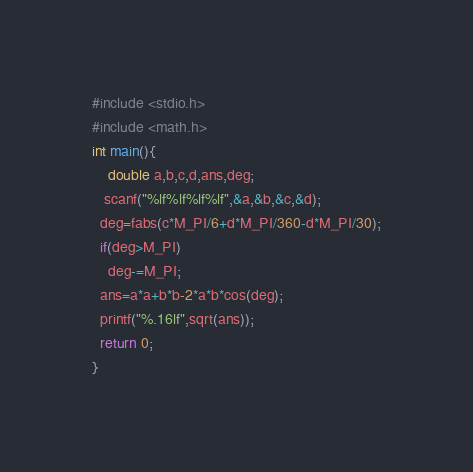<code> <loc_0><loc_0><loc_500><loc_500><_C_>#include <stdio.h>
#include <math.h>
int main(){
    double a,b,c,d,ans,deg;
   scanf("%lf%lf%lf%lf",&a,&b,&c,&d);
  deg=fabs(c*M_PI/6+d*M_PI/360-d*M_PI/30);
  if(deg>M_PI)
    deg-=M_PI;
  ans=a*a+b*b-2*a*b*cos(deg);
  printf("%.16lf",sqrt(ans));
  return 0;
}
</code> 